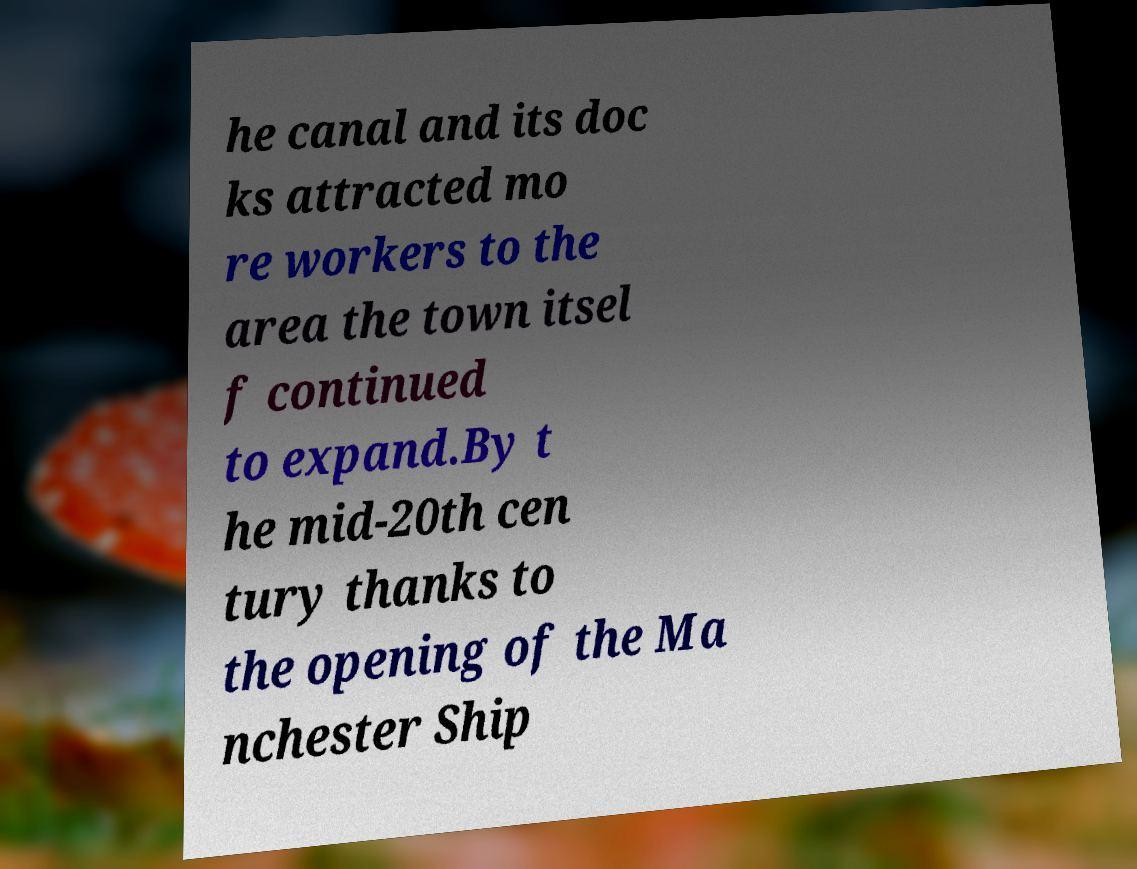Please identify and transcribe the text found in this image. he canal and its doc ks attracted mo re workers to the area the town itsel f continued to expand.By t he mid-20th cen tury thanks to the opening of the Ma nchester Ship 